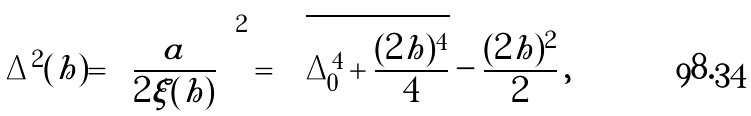Convert formula to latex. <formula><loc_0><loc_0><loc_500><loc_500>\Delta ^ { 2 } ( h ) = \left ( \frac { a } { 2 \xi ( h ) } \right ) ^ { 2 } = \sqrt { \Delta _ { 0 } ^ { 4 } + \frac { ( 2 h ) ^ { 4 } } 4 } - \frac { ( 2 h ) ^ { 2 } } 2 \, ,</formula> 